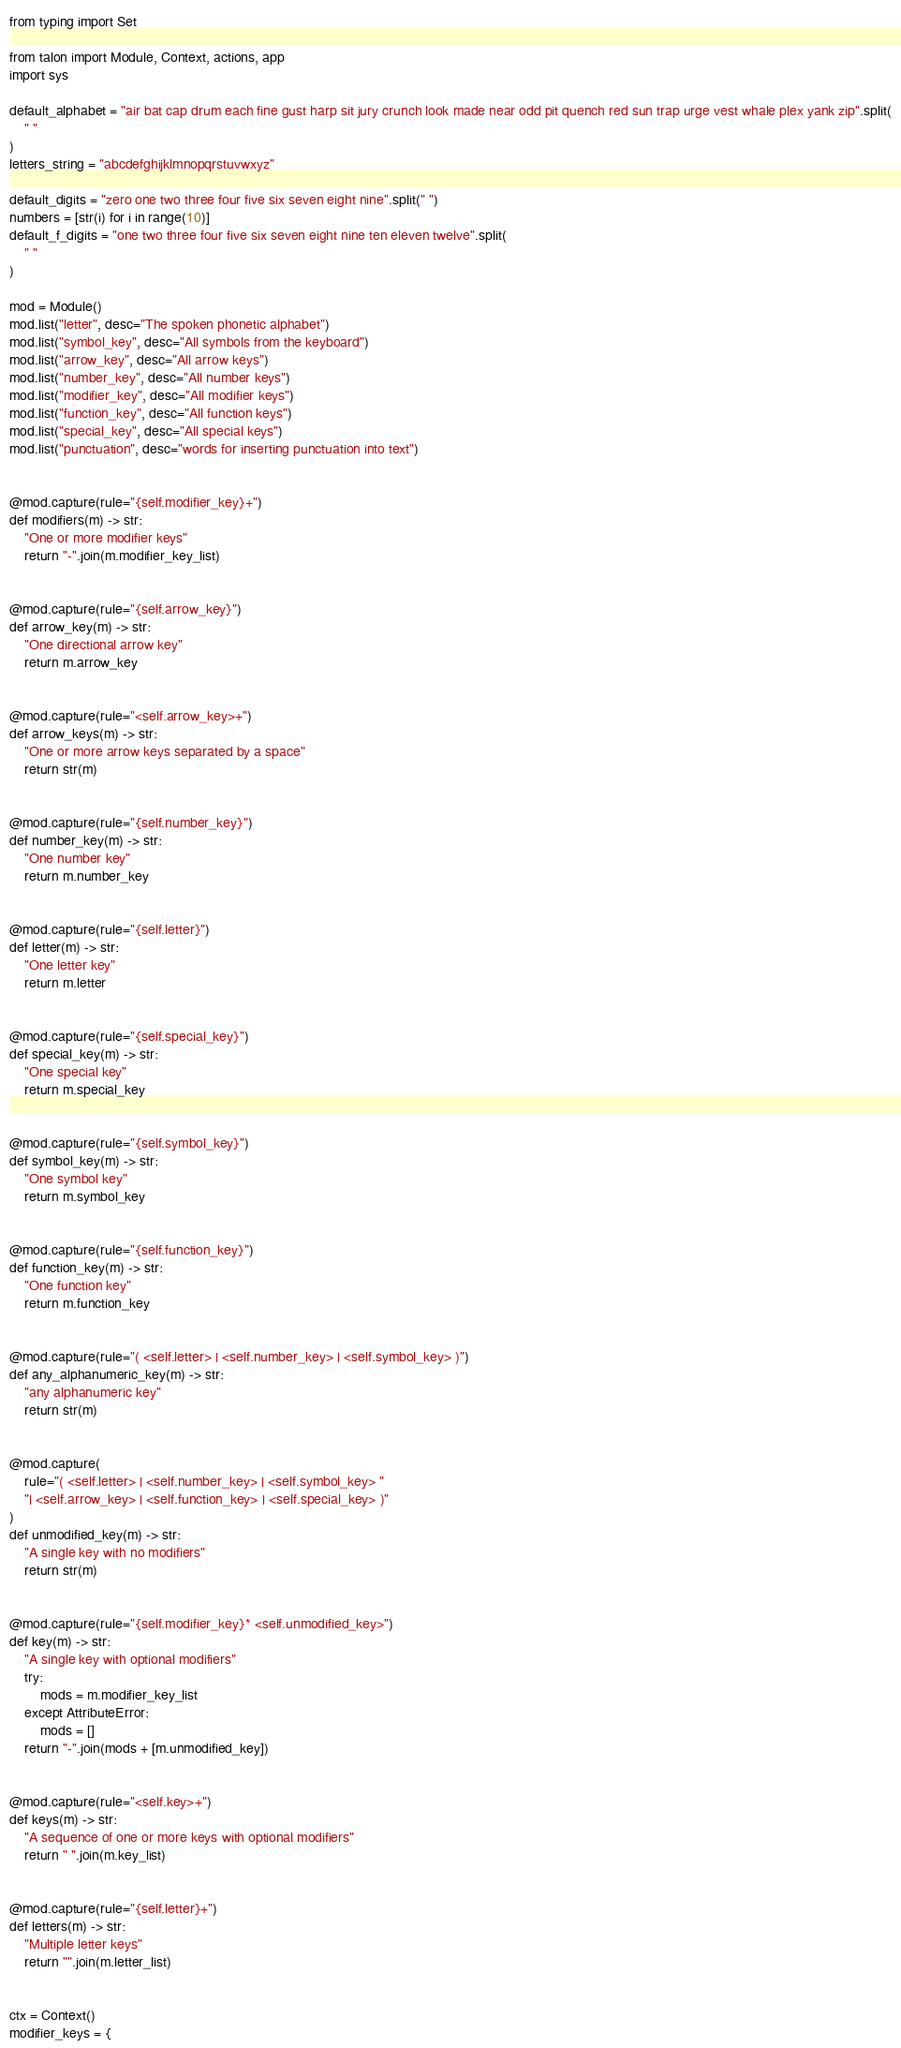<code> <loc_0><loc_0><loc_500><loc_500><_Python_>from typing import Set

from talon import Module, Context, actions, app
import sys

default_alphabet = "air bat cap drum each fine gust harp sit jury crunch look made near odd pit quench red sun trap urge vest whale plex yank zip".split(
    " "
)
letters_string = "abcdefghijklmnopqrstuvwxyz"

default_digits = "zero one two three four five six seven eight nine".split(" ")
numbers = [str(i) for i in range(10)]
default_f_digits = "one two three four five six seven eight nine ten eleven twelve".split(
    " "
)

mod = Module()
mod.list("letter", desc="The spoken phonetic alphabet")
mod.list("symbol_key", desc="All symbols from the keyboard")
mod.list("arrow_key", desc="All arrow keys")
mod.list("number_key", desc="All number keys")
mod.list("modifier_key", desc="All modifier keys")
mod.list("function_key", desc="All function keys")
mod.list("special_key", desc="All special keys")
mod.list("punctuation", desc="words for inserting punctuation into text")


@mod.capture(rule="{self.modifier_key}+")
def modifiers(m) -> str:
    "One or more modifier keys"
    return "-".join(m.modifier_key_list)


@mod.capture(rule="{self.arrow_key}")
def arrow_key(m) -> str:
    "One directional arrow key"
    return m.arrow_key


@mod.capture(rule="<self.arrow_key>+")
def arrow_keys(m) -> str:
    "One or more arrow keys separated by a space"
    return str(m)


@mod.capture(rule="{self.number_key}")
def number_key(m) -> str:
    "One number key"
    return m.number_key


@mod.capture(rule="{self.letter}")
def letter(m) -> str:
    "One letter key"
    return m.letter


@mod.capture(rule="{self.special_key}")
def special_key(m) -> str:
    "One special key"
    return m.special_key


@mod.capture(rule="{self.symbol_key}")
def symbol_key(m) -> str:
    "One symbol key"
    return m.symbol_key


@mod.capture(rule="{self.function_key}")
def function_key(m) -> str:
    "One function key"
    return m.function_key


@mod.capture(rule="( <self.letter> | <self.number_key> | <self.symbol_key> )")
def any_alphanumeric_key(m) -> str:
    "any alphanumeric key"
    return str(m)


@mod.capture(
    rule="( <self.letter> | <self.number_key> | <self.symbol_key> "
    "| <self.arrow_key> | <self.function_key> | <self.special_key> )"
)
def unmodified_key(m) -> str:
    "A single key with no modifiers"
    return str(m)


@mod.capture(rule="{self.modifier_key}* <self.unmodified_key>")
def key(m) -> str:
    "A single key with optional modifiers"
    try:
        mods = m.modifier_key_list
    except AttributeError:
        mods = []
    return "-".join(mods + [m.unmodified_key])


@mod.capture(rule="<self.key>+")
def keys(m) -> str:
    "A sequence of one or more keys with optional modifiers"
    return " ".join(m.key_list)


@mod.capture(rule="{self.letter}+")
def letters(m) -> str:
    "Multiple letter keys"
    return "".join(m.letter_list)


ctx = Context()
modifier_keys = {</code> 